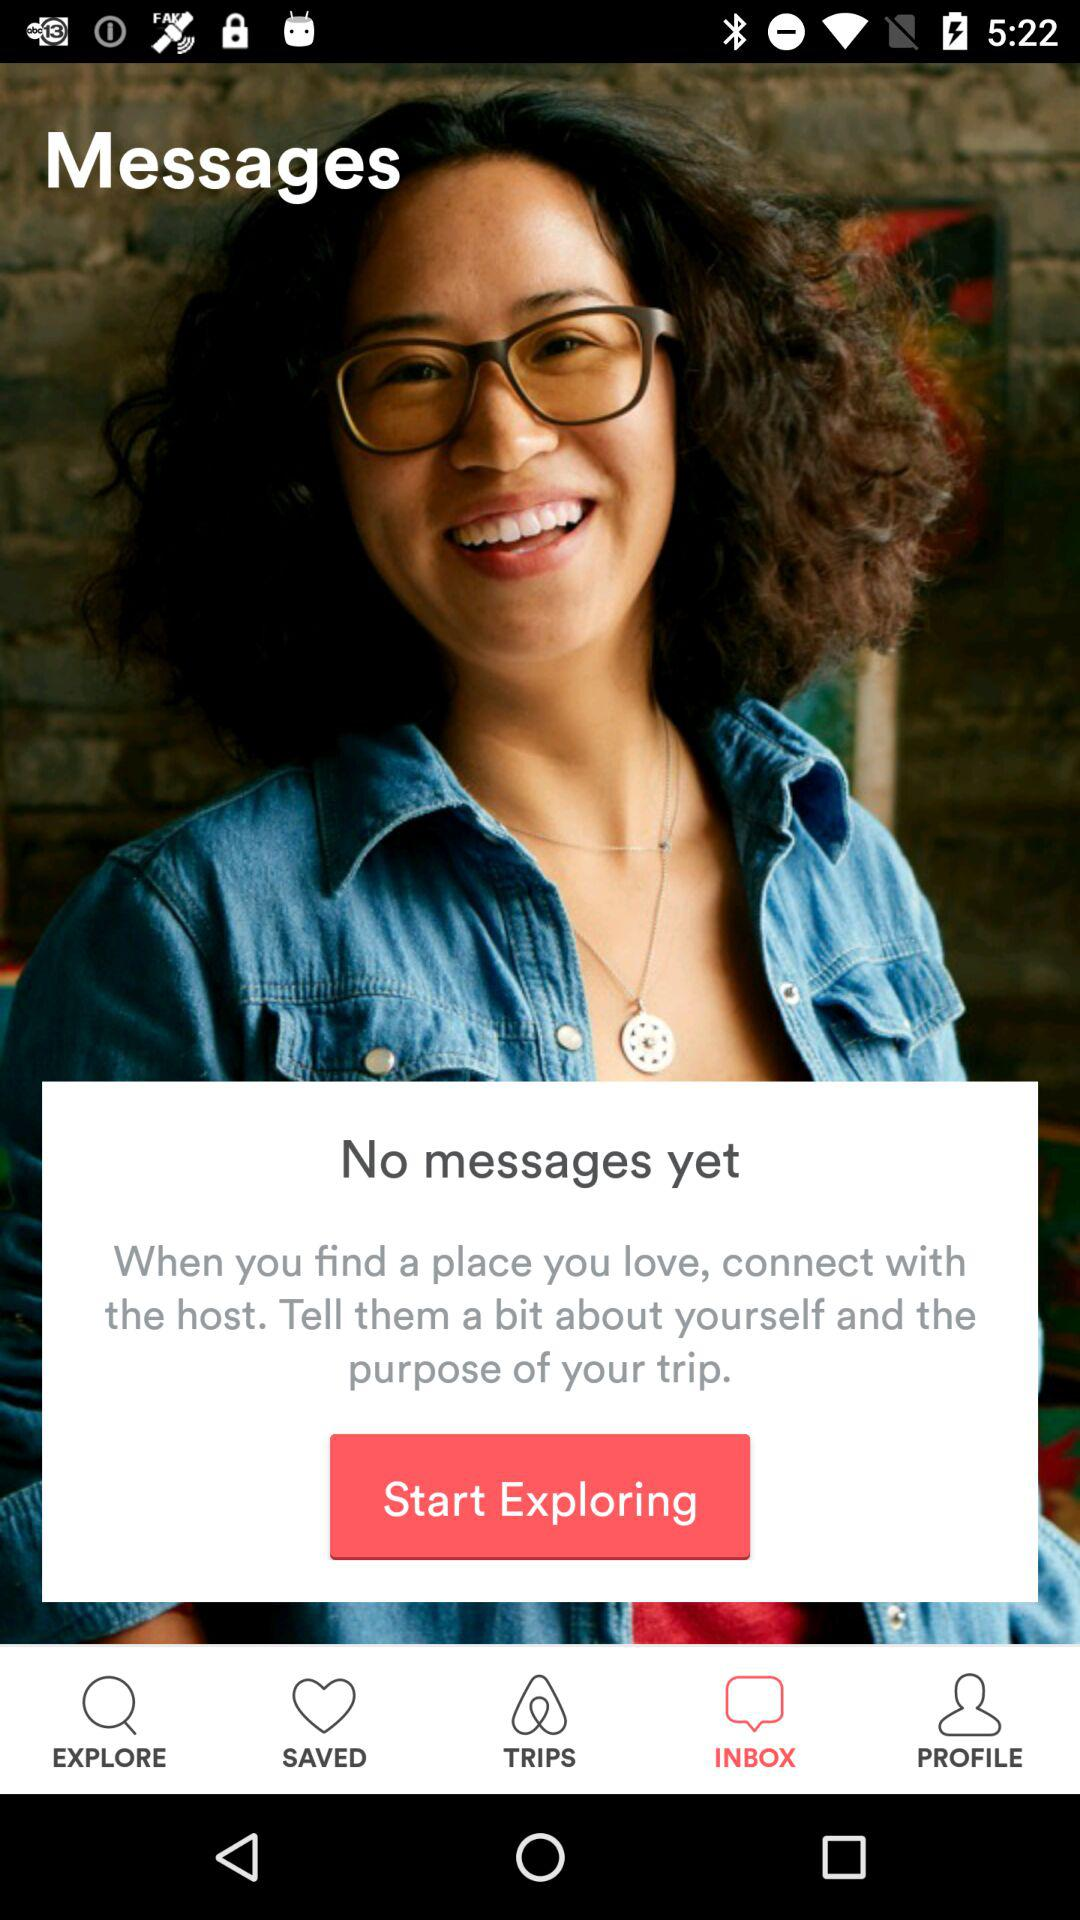How many notifications are there in "SAVED"?
When the provided information is insufficient, respond with <no answer>. <no answer> 